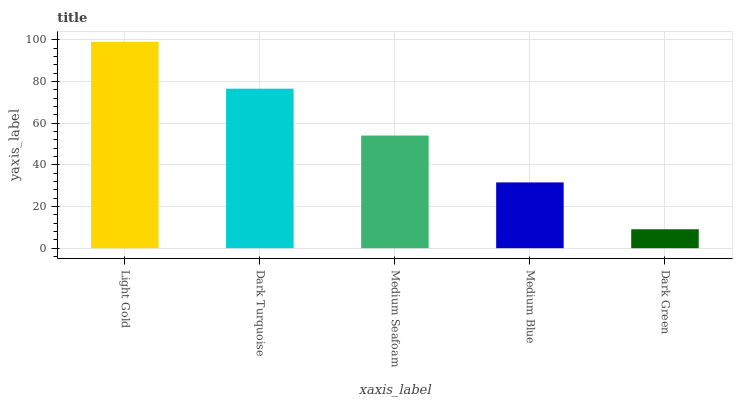Is Dark Green the minimum?
Answer yes or no. Yes. Is Light Gold the maximum?
Answer yes or no. Yes. Is Dark Turquoise the minimum?
Answer yes or no. No. Is Dark Turquoise the maximum?
Answer yes or no. No. Is Light Gold greater than Dark Turquoise?
Answer yes or no. Yes. Is Dark Turquoise less than Light Gold?
Answer yes or no. Yes. Is Dark Turquoise greater than Light Gold?
Answer yes or no. No. Is Light Gold less than Dark Turquoise?
Answer yes or no. No. Is Medium Seafoam the high median?
Answer yes or no. Yes. Is Medium Seafoam the low median?
Answer yes or no. Yes. Is Dark Green the high median?
Answer yes or no. No. Is Dark Green the low median?
Answer yes or no. No. 